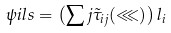Convert formula to latex. <formula><loc_0><loc_0><loc_500><loc_500>\psi i l s = \left ( \sum j \tilde { \tau } _ { i j } ( \lll ) \right ) l _ { i }</formula> 